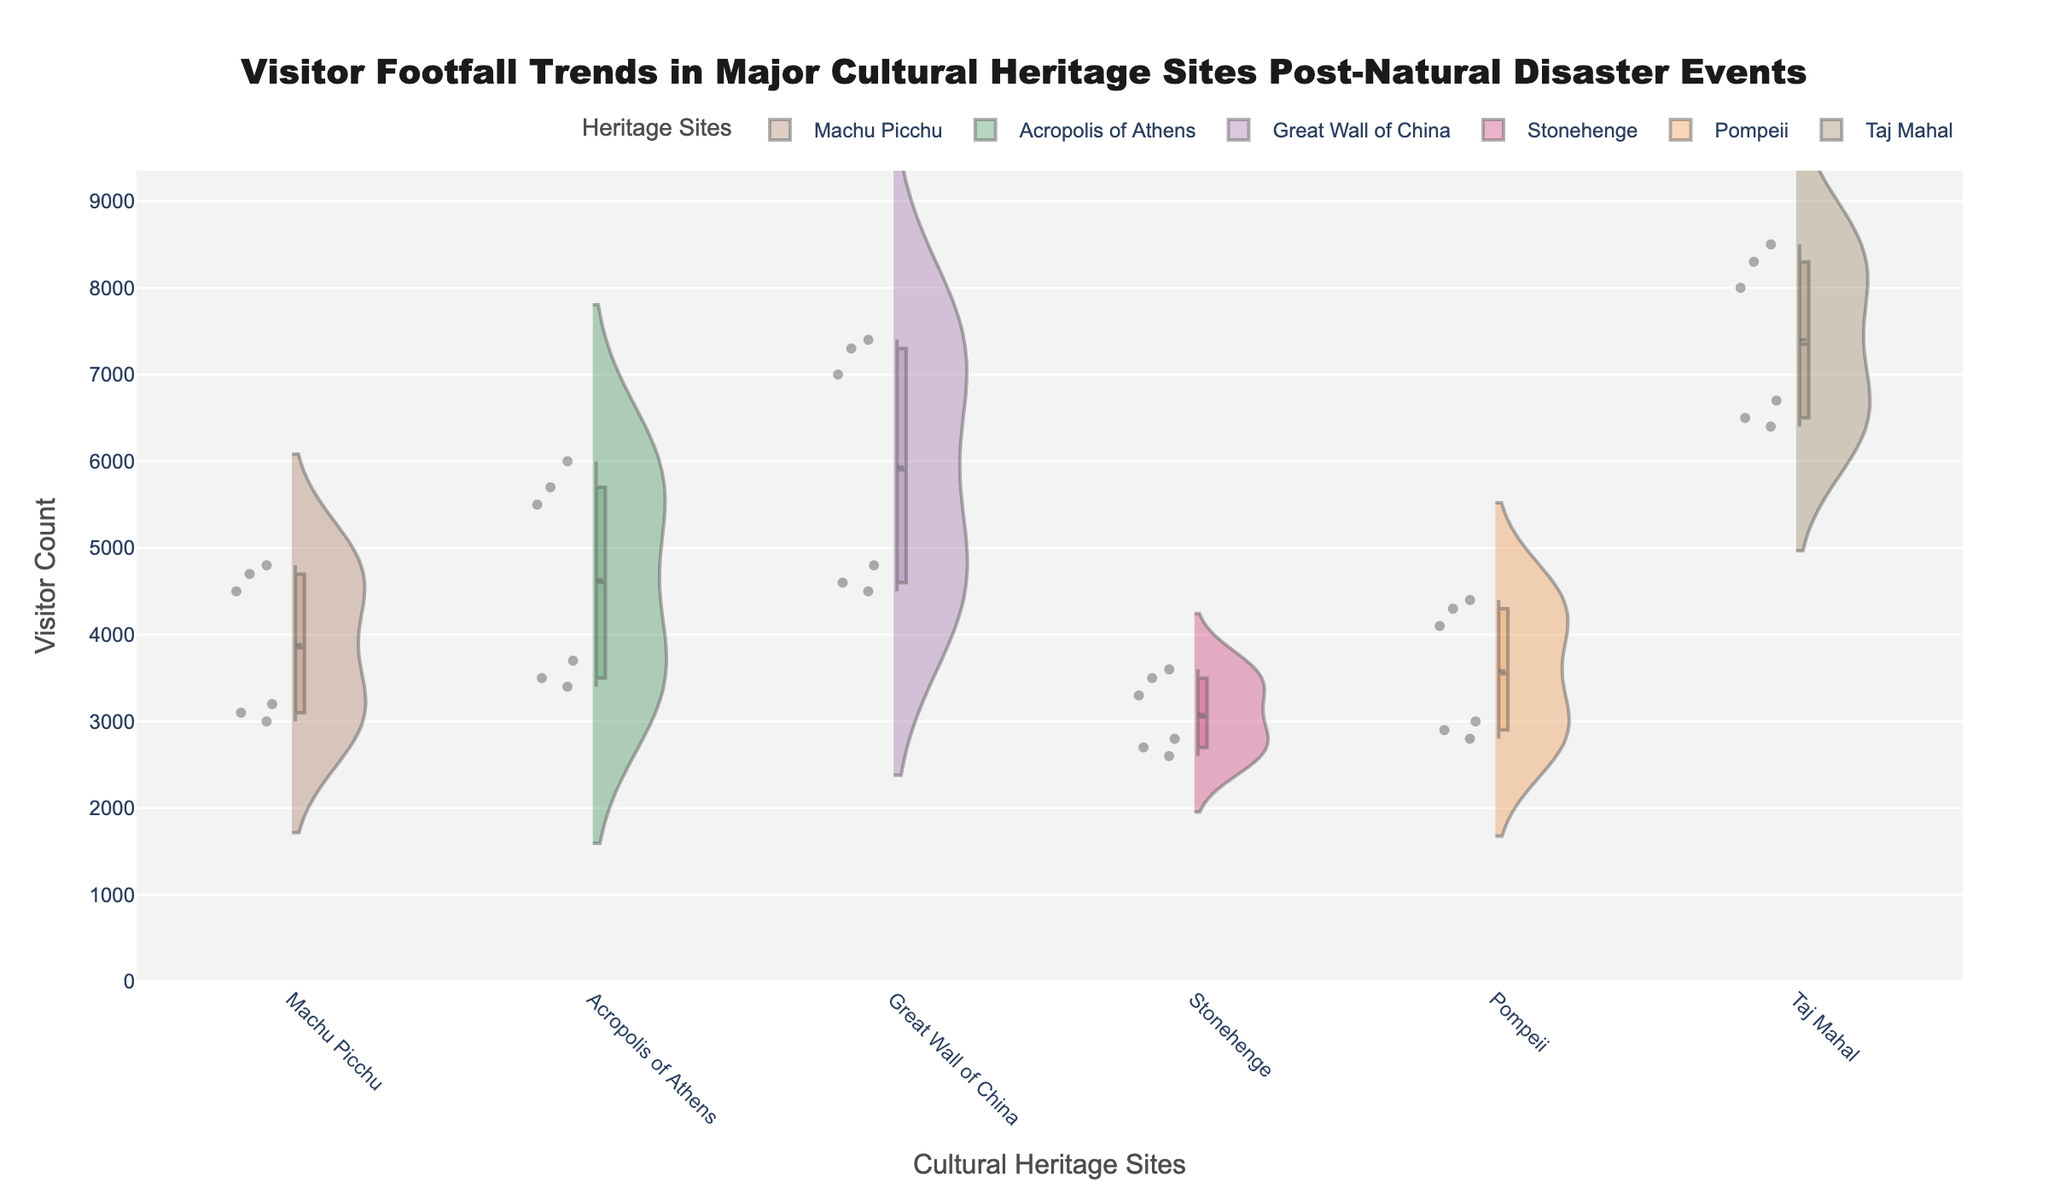What is the title of the figure? The title is typically located at the top of the figure and provides a concise description of what the plot represents. In this case, the title is bold and prominently displayed.
Answer: Visitor Footfall Trends in Major Cultural Heritage Sites Post-Natural Disaster Events Which site has the highest pre-disaster visitor count in February 2022? To find this, look for the specific site marked for February 2022 and identify the highest value in the pre-disaster section.
Answer: Taj Mahal How do visitor counts at Machu Picchu compare pre- and post-disaster for January 2020? Locate Machu Picchu, January 2020. Compare the heights of the box plots for pre- and post-disaster visitor counts.
Answer: Pre-disaster: 4500, Post-disaster: 3200 Which site experienced the highest drop in visitor count post-disaster in February? To determine this, calculate the difference between pre- and post-disaster counts for each site in February. Identify the largest drop.
Answer: Great Wall of China What is the typical range of post-disaster visitor counts at Stonehenge? For Stonehenge, examine the spread of the box plot in the post-disaster section to determine the range.
Answer: 2600 - 2800 Which site shows the smallest difference between pre- and post-disaster visitor counts for March? Compare the differences between pre- and post-disaster counts for each site in March. Identify the smallest difference.
Answer: Great Wall of China Do any sites have overlapping pre- and post-disaster visitor counts? Check the violin plots for any overlapping areas between pre- and post-disaster visitor counts in each site.
Answer: No What patterns are noticeable in the overall visitor counts across all sites pre- and post-disaster? Observe the general trends in the height and spread of the box plots and violin plots for pre- and post-disaster counts.
Answer: Post-disaster counts are consistently lower than pre-disaster How do the visitor counts at the Acropolis of Athens in January 2021 compare to those at Pompeii in the same month? Compare the box plot values for pre- and post-disaster counts for Acropolis of Athens and Pompeii in January 2021.
Answer: Acropolis of Athens: Pre: 5500, Post: 3700; Pompeii: Pre: 4100, Post: 3000 